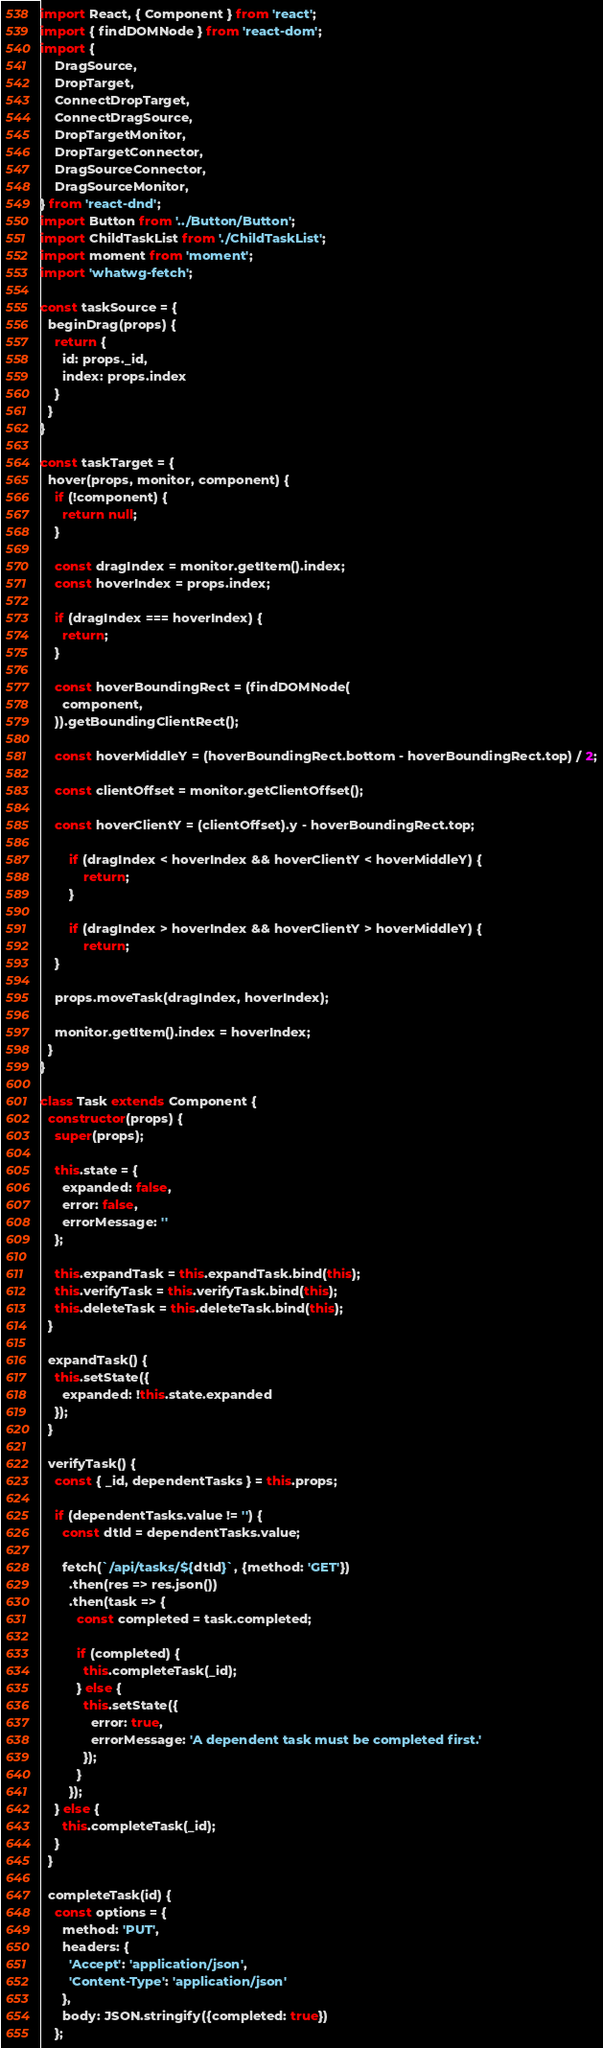<code> <loc_0><loc_0><loc_500><loc_500><_JavaScript_>import React, { Component } from 'react';
import { findDOMNode } from 'react-dom';
import {
	DragSource,
	DropTarget,
	ConnectDropTarget,
	ConnectDragSource,
	DropTargetMonitor,
	DropTargetConnector,
	DragSourceConnector,
	DragSourceMonitor,
} from 'react-dnd';
import Button from '../Button/Button';
import ChildTaskList from './ChildTaskList';
import moment from 'moment';
import 'whatwg-fetch';

const taskSource = {
  beginDrag(props) {
    return {
      id: props._id,
      index: props.index
    }
  }
}

const taskTarget = {
  hover(props, monitor, component) {
    if (!component) {
      return null;
    }

    const dragIndex = monitor.getItem().index;
    const hoverIndex = props.index;

    if (dragIndex === hoverIndex) {
      return;
    }

    const hoverBoundingRect = (findDOMNode(
      component,
    )).getBoundingClientRect();

    const hoverMiddleY = (hoverBoundingRect.bottom - hoverBoundingRect.top) / 2;

    const clientOffset = monitor.getClientOffset();

    const hoverClientY = (clientOffset).y - hoverBoundingRect.top;

		if (dragIndex < hoverIndex && hoverClientY < hoverMiddleY) {
			return;
		}

		if (dragIndex > hoverIndex && hoverClientY > hoverMiddleY) {
			return;
    }
    
    props.moveTask(dragIndex, hoverIndex);

    monitor.getItem().index = hoverIndex;
  }
}

class Task extends Component {
  constructor(props) {
    super(props);

    this.state = {
      expanded: false,
      error: false,
      errorMessage: ''
    };

    this.expandTask = this.expandTask.bind(this);
    this.verifyTask = this.verifyTask.bind(this);
    this.deleteTask = this.deleteTask.bind(this);
  }

  expandTask() {
    this.setState({
      expanded: !this.state.expanded
    });
  }

  verifyTask() {
    const { _id, dependentTasks } = this.props;

    if (dependentTasks.value != '') {
      const dtId = dependentTasks.value;

      fetch(`/api/tasks/${dtId}`, {method: 'GET'})
        .then(res => res.json())
        .then(task => {
          const completed = task.completed;

          if (completed) {
            this.completeTask(_id);
          } else {
            this.setState({
              error: true,
              errorMessage: 'A dependent task must be completed first.'
            });
          }
        });
    } else {
      this.completeTask(_id);
    }
  }

  completeTask(id) {
    const options = {
      method: 'PUT',
      headers: {
        'Accept': 'application/json',
        'Content-Type': 'application/json'
      },
      body: JSON.stringify({completed: true})
    };
</code> 